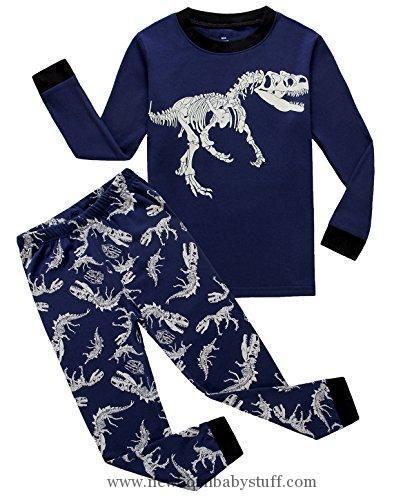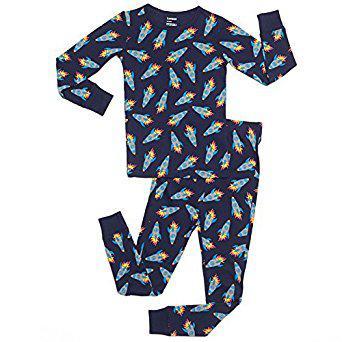The first image is the image on the left, the second image is the image on the right. Evaluate the accuracy of this statement regarding the images: "At least one of the outfits has a brightly colored collar and brightly colored cuffs around the sleeves or ankles.". Is it true? Answer yes or no. No. The first image is the image on the left, the second image is the image on the right. For the images displayed, is the sentence "All the pajamas have long sleeves with small cuffs." factually correct? Answer yes or no. Yes. 